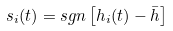<formula> <loc_0><loc_0><loc_500><loc_500>s _ { i } ( t ) = s g n \left [ h _ { i } ( t ) - \bar { h } \right ]</formula> 